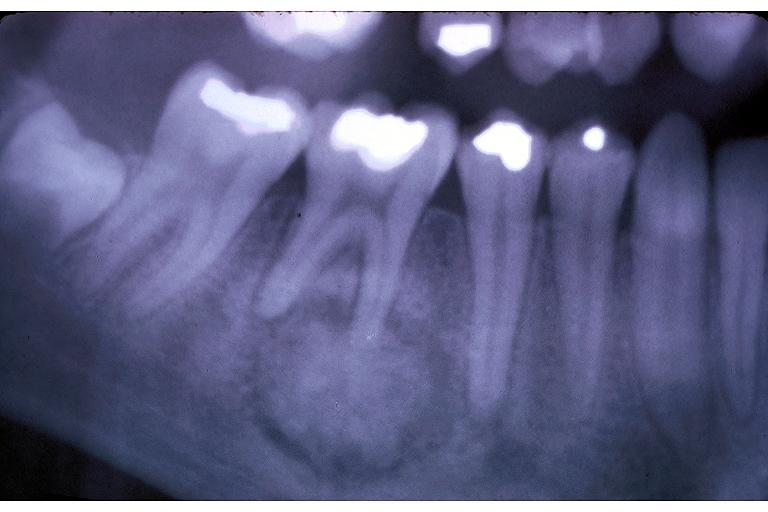what is present?
Answer the question using a single word or phrase. Oral 